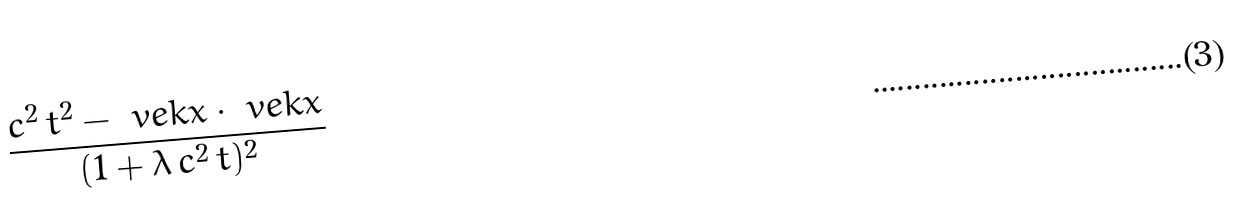<formula> <loc_0><loc_0><loc_500><loc_500>\frac { c ^ { 2 } \, t ^ { 2 } - \ v e k { x } \cdot \ v e k { x } } { ( 1 + \lambda \, c ^ { 2 } \, t ) ^ { 2 } }</formula> 